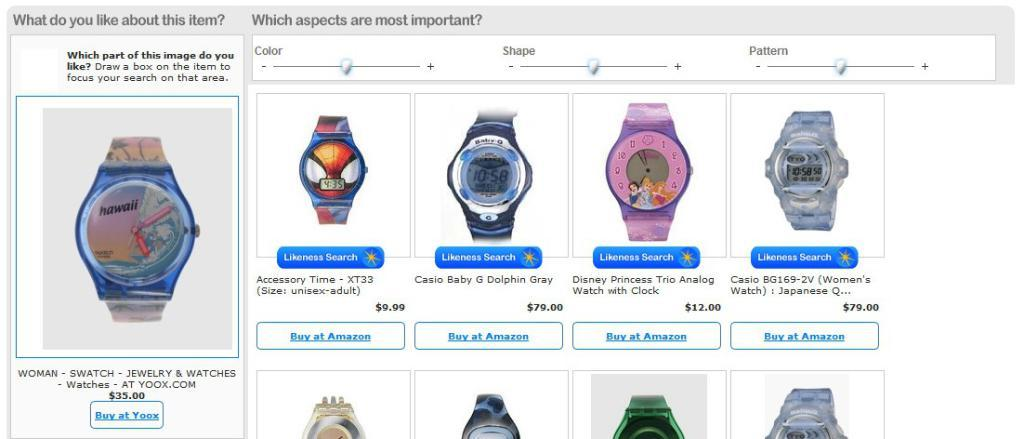<image>
Share a concise interpretation of the image provided. A website shows many different watches including on that says hawaii on it. 